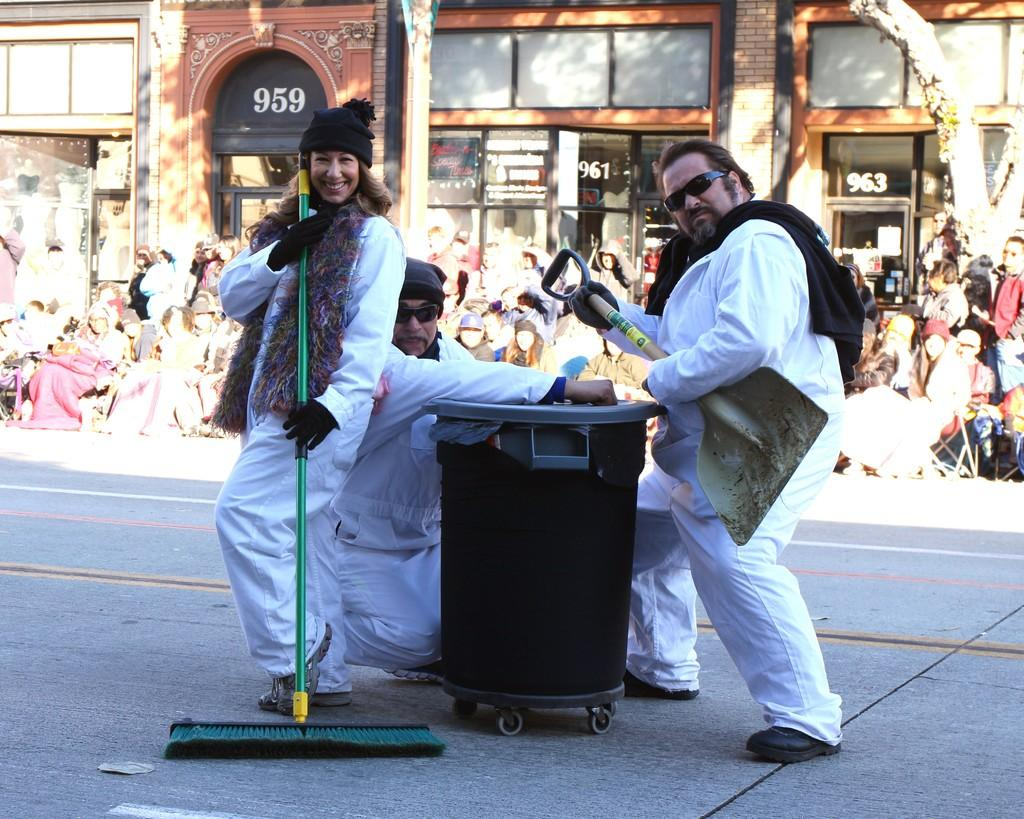<image>
Present a compact description of the photo's key features. A building is numbered 959 with people standing in front of it with brooms and shovels. 